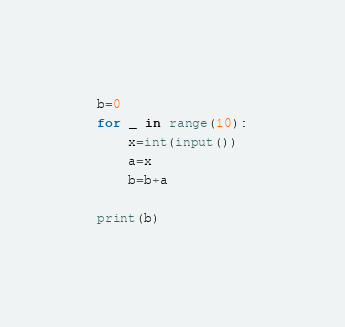Convert code to text. <code><loc_0><loc_0><loc_500><loc_500><_Python_>b=0
for _ in range(10):
    x=int(input())
    a=x
    b=b+a
    
print(b)


</code> 